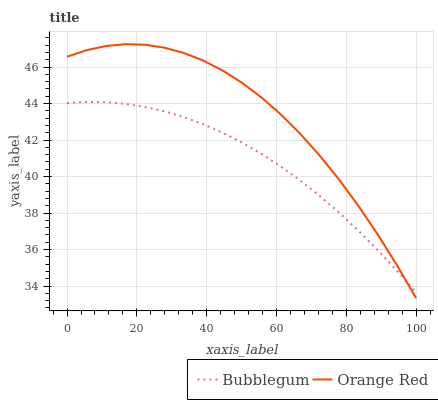Does Bubblegum have the minimum area under the curve?
Answer yes or no. Yes. Does Orange Red have the maximum area under the curve?
Answer yes or no. Yes. Does Bubblegum have the maximum area under the curve?
Answer yes or no. No. Is Bubblegum the smoothest?
Answer yes or no. Yes. Is Orange Red the roughest?
Answer yes or no. Yes. Is Bubblegum the roughest?
Answer yes or no. No. Does Orange Red have the lowest value?
Answer yes or no. Yes. Does Bubblegum have the lowest value?
Answer yes or no. No. Does Orange Red have the highest value?
Answer yes or no. Yes. Does Bubblegum have the highest value?
Answer yes or no. No. Does Orange Red intersect Bubblegum?
Answer yes or no. Yes. Is Orange Red less than Bubblegum?
Answer yes or no. No. Is Orange Red greater than Bubblegum?
Answer yes or no. No. 